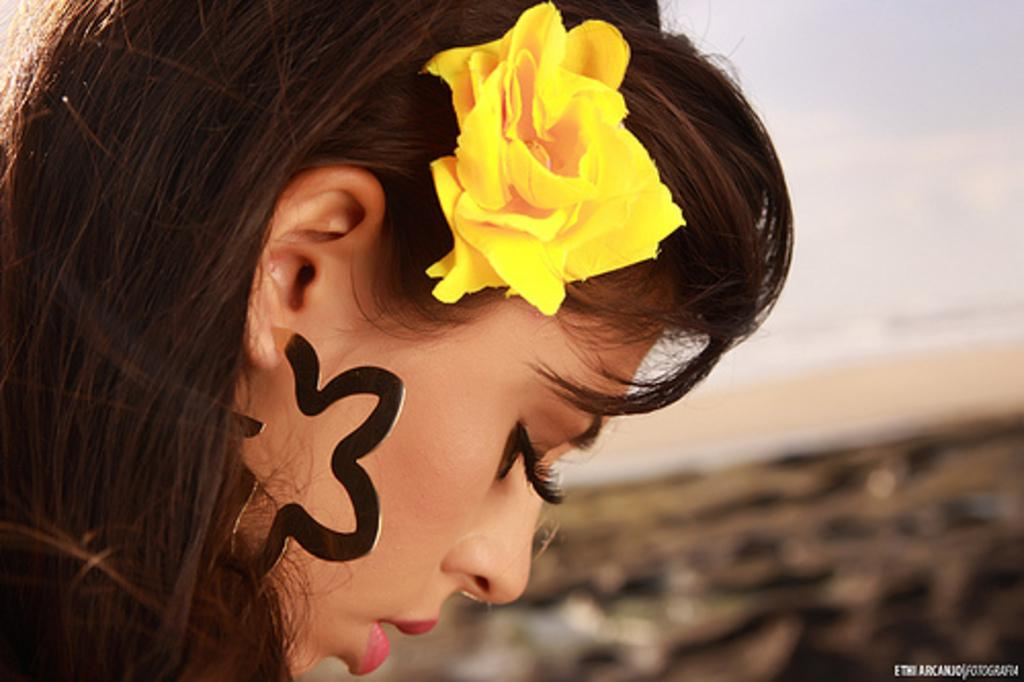Who is the main subject in the image? There is a girl in the image. What is the girl's perspective in the image? The girl has a close view in the image. What accessory is the girl wearing in her hair? The girl is wearing a yellow color flower in her hair. How would you describe the background of the image? The background of the image is blurred. What type of beetle can be seen crawling on the girl's shoulder in the image? There is no beetle present on the girl's shoulder in the image. What occupation does the girl have in the image? The image does not provide any information about the girl's occupation. 